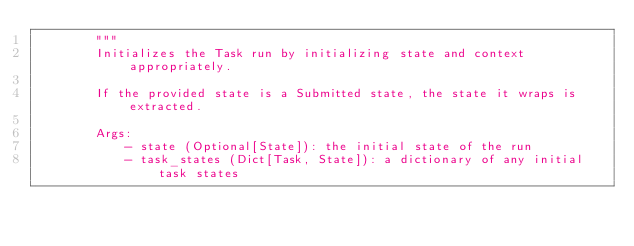<code> <loc_0><loc_0><loc_500><loc_500><_Python_>        """
        Initializes the Task run by initializing state and context appropriately.

        If the provided state is a Submitted state, the state it wraps is extracted.

        Args:
            - state (Optional[State]): the initial state of the run
            - task_states (Dict[Task, State]): a dictionary of any initial task states</code> 